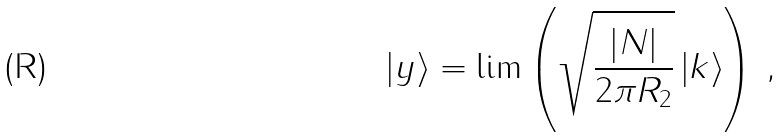Convert formula to latex. <formula><loc_0><loc_0><loc_500><loc_500>\left | y \right \rangle = \lim \left ( \sqrt { \frac { | N | } { 2 \pi R _ { 2 } } } \left | k \right \rangle \right ) \, ,</formula> 